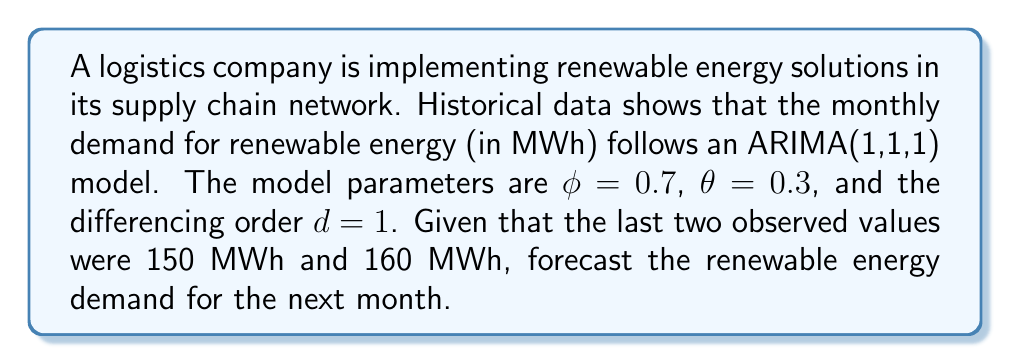What is the answer to this math problem? 1) The ARIMA(1,1,1) model is given by:
   $$(1 - \phi B)(1 - B)Y_t = (1 + \theta B)\varepsilon_t$$

2) Expanding this equation:
   $$Y_t - (1 + \phi)Y_{t-1} + \phi Y_{t-2} = \varepsilon_t + \theta \varepsilon_{t-1}$$

3) For forecasting, we set future error terms to their expected value of 0:
   $$\hat{Y}_t = (1 + \phi)\hat{Y}_{t-1} - \phi \hat{Y}_{t-2} + \theta \varepsilon_{t-1}$$

4) We need to calculate $\varepsilon_{t-1}$:
   $$\varepsilon_{t-1} = Y_{t-1} - \hat{Y}_{t-1}$$
   $$\hat{Y}_{t-1} = Y_{t-2} + \phi(Y_{t-2} - Y_{t-3})$$
   $$\hat{Y}_{t-1} = 150 + 0.7(150 - 140) = 157$$
   $$\varepsilon_{t-1} = 160 - 157 = 3$$

5) Now we can forecast:
   $$\hat{Y}_t = (1 + 0.7)(160) - 0.7(150) + 0.3(3)$$
   $$\hat{Y}_t = 272 - 105 + 0.9 = 167.9$$

Therefore, the forecast for the next month's renewable energy demand is approximately 167.9 MWh.
Answer: 167.9 MWh 